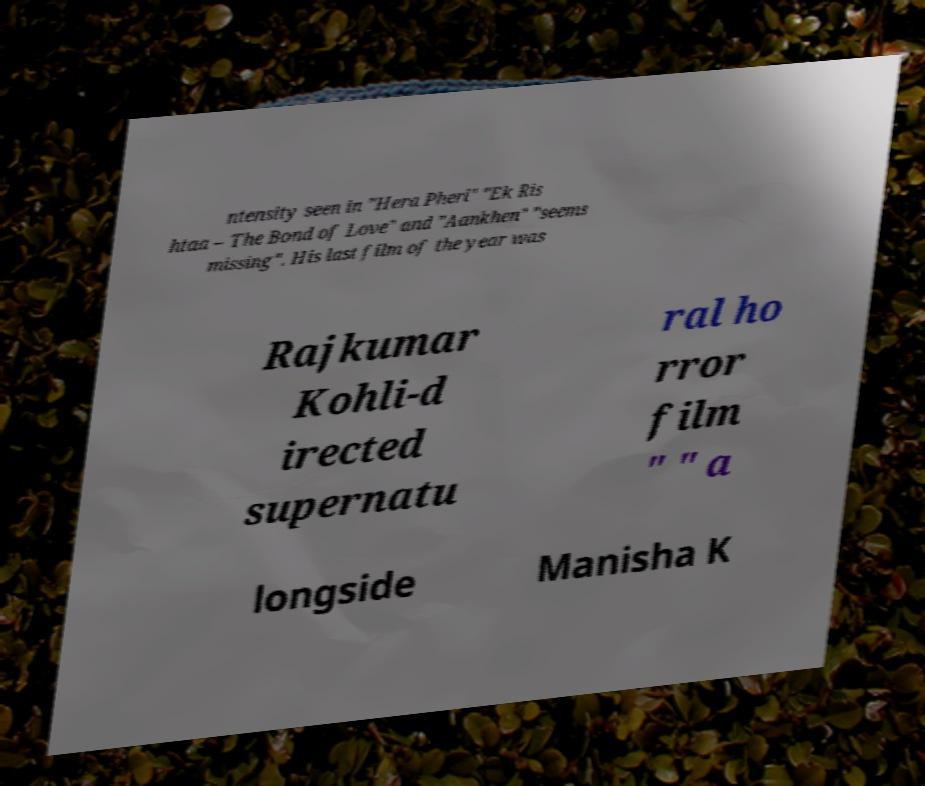Can you read and provide the text displayed in the image?This photo seems to have some interesting text. Can you extract and type it out for me? ntensity seen in "Hera Pheri" "Ek Ris htaa – The Bond of Love" and "Aankhen" "seems missing". His last film of the year was Rajkumar Kohli-d irected supernatu ral ho rror film " " a longside Manisha K 